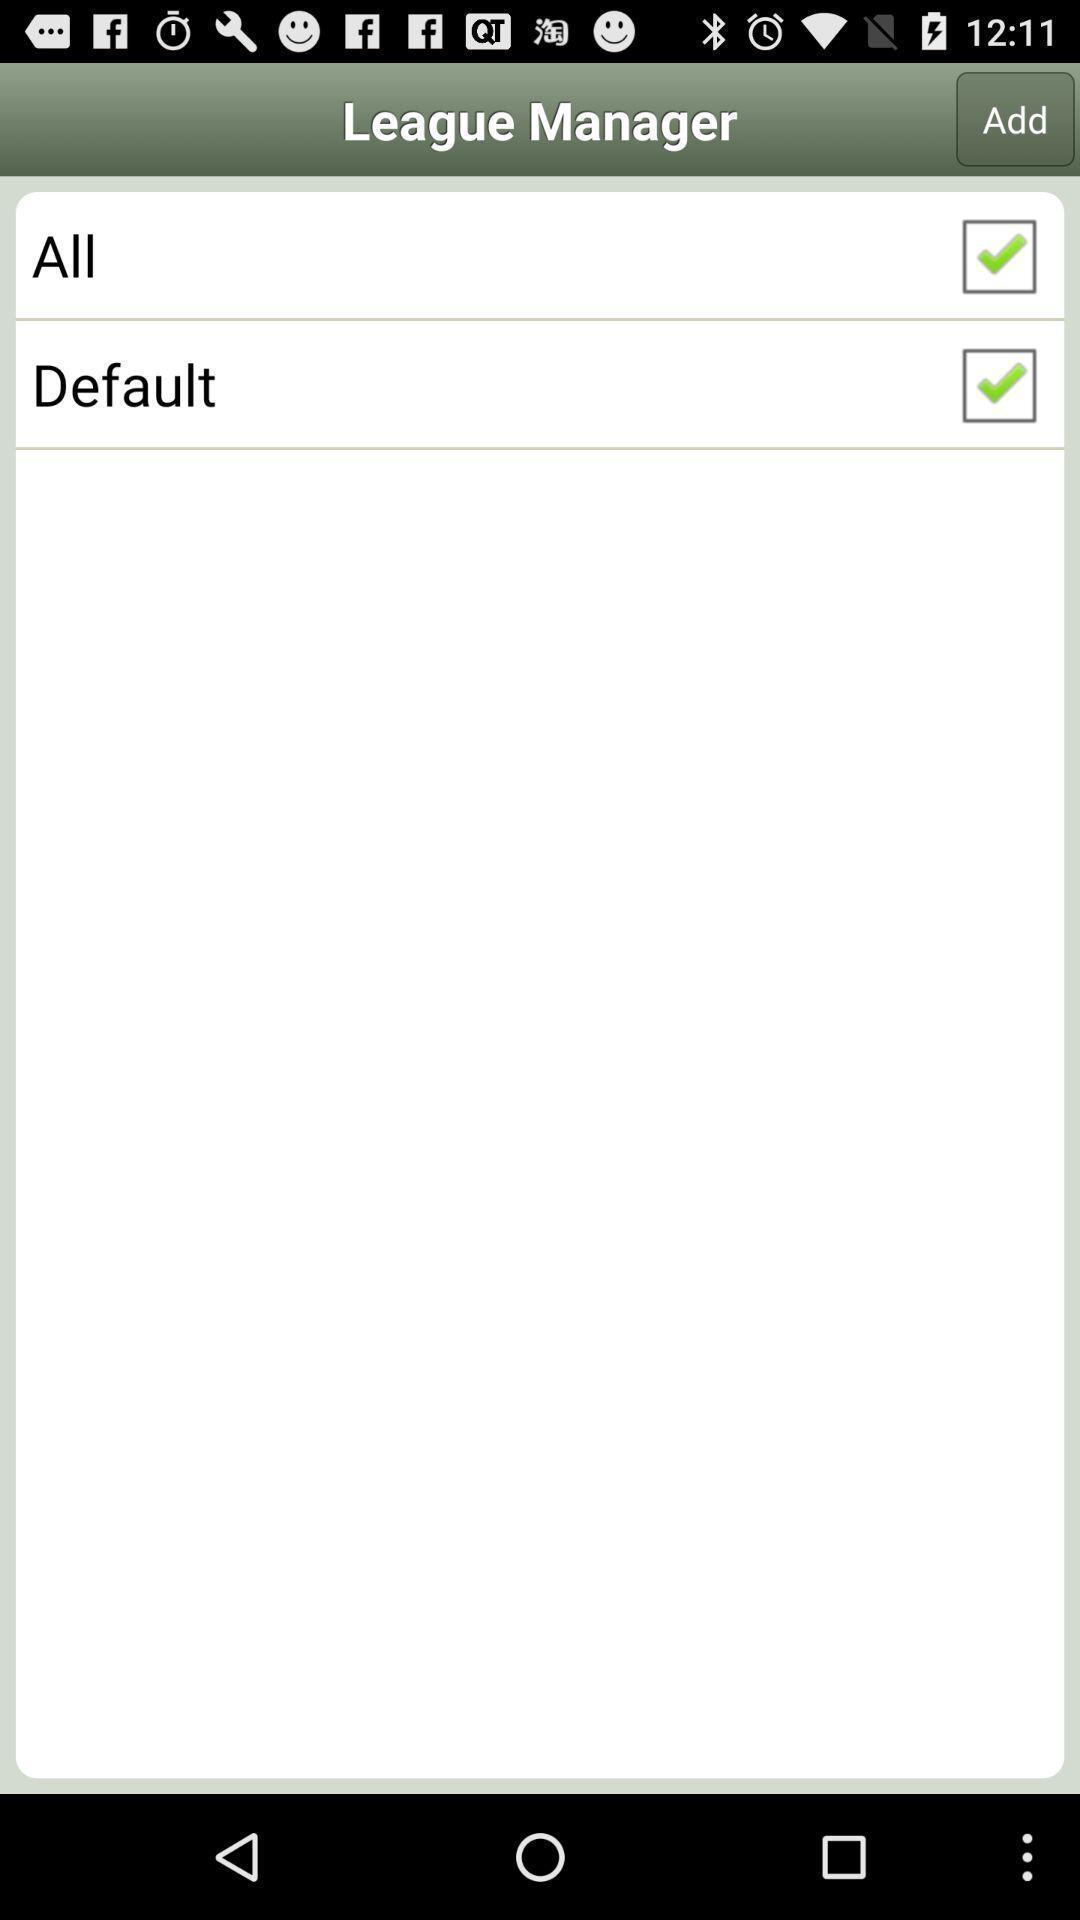Summarize the information in this screenshot. Page showing baseball or softball game app. 